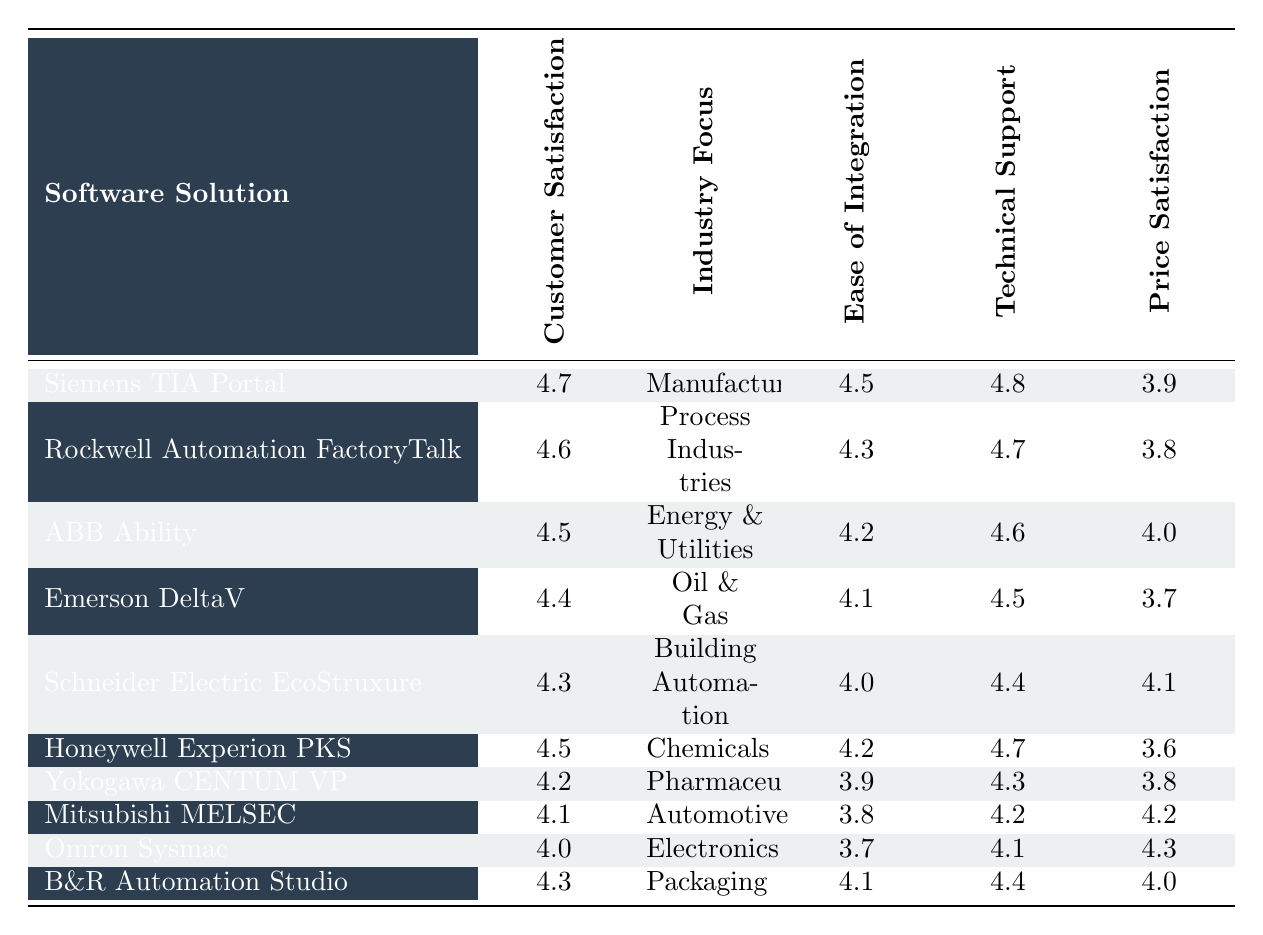What is the customer satisfaction rating for Siemens TIA Portal? The table lists Siemens TIA Portal with a customer satisfaction rating of 4.7.
Answer: 4.7 Which software solution has the highest customer satisfaction rating? By looking at the ratings, Siemens TIA Portal at 4.7 has the highest satisfaction rating compared to others.
Answer: Siemens TIA Portal What is the average ease of integration score across all software solutions? To find the average, sum the ease of integration scores: (4.5 + 4.3 + 4.2 + 4.1 + 4.0 + 4.2 + 3.9 + 3.8 + 3.7 + 4.1) = 42.8, and divide by 10 (the number of solutions), which equals 4.28.
Answer: 4.28 Is the technical support score for Honeywell Experion PKS higher than 4.5? The technical support score for Honeywell Experion PKS is 4.7, which is indeed higher than 4.5.
Answer: Yes Which industry focus has the lowest customer satisfaction rating and what is that rating? Looking at the customer satisfaction ratings, Yokogawa CENTUM VP has the lowest rating of 4.2 in the Pharmaceuticals industry.
Answer: Pharmaceuticals, 4.2 What is the difference between the highest and lowest price satisfaction ratings? The highest price satisfaction rating is 4.2 (Mitsubishi MELSEC) and the lowest is 3.6 (Honeywell Experion PKS). The difference is 4.2 - 3.6 = 0.6.
Answer: 0.6 Which software solution has the lowest ease of integration score? By checking the table, Omron Sysmac has the lowest ease of integration score of 3.7.
Answer: Omron Sysmac Are most software solutions in the table focused on manufacturing or process industries? The table shows that out of the 10 solutions listed, only Siemens TIA Portal is specifically for Manufacturing, while Rockwell Automation FactoryTalk is focused on Process Industries, implying an equal distribution.
Answer: No What is the technical support score for the software solution that scored 4.3 in customer satisfaction? Schneider Electric EcoStruxure and B&R Automation Studio both scored 4.3 in customer satisfaction; their technical support scores are 4.4 and 4.4 respectively.
Answer: 4.4 (for both) Which software solution has a price satisfaction of 4.0 or higher and what is its customer satisfaction rating? The solutions that meet the price satisfaction criterion of 4.0 or higher are ABB Ability (4.5), Schneider Electric EcoStruxure (4.3), and Mitsubishi MELSEC (4.1); their customer satisfaction ratings are 4.5, 4.3, and 4.1, respectively.
Answer: ABB Ability, 4.5 